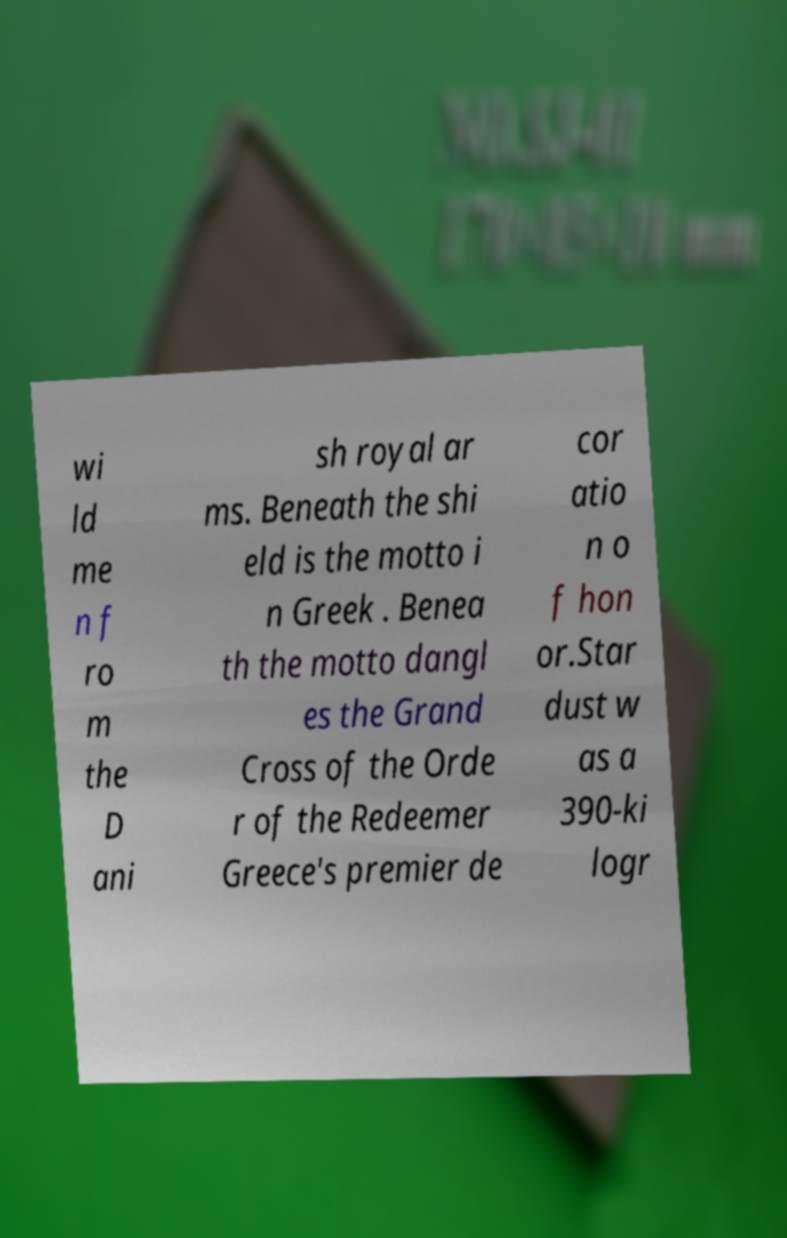Could you extract and type out the text from this image? wi ld me n f ro m the D ani sh royal ar ms. Beneath the shi eld is the motto i n Greek . Benea th the motto dangl es the Grand Cross of the Orde r of the Redeemer Greece's premier de cor atio n o f hon or.Star dust w as a 390-ki logr 